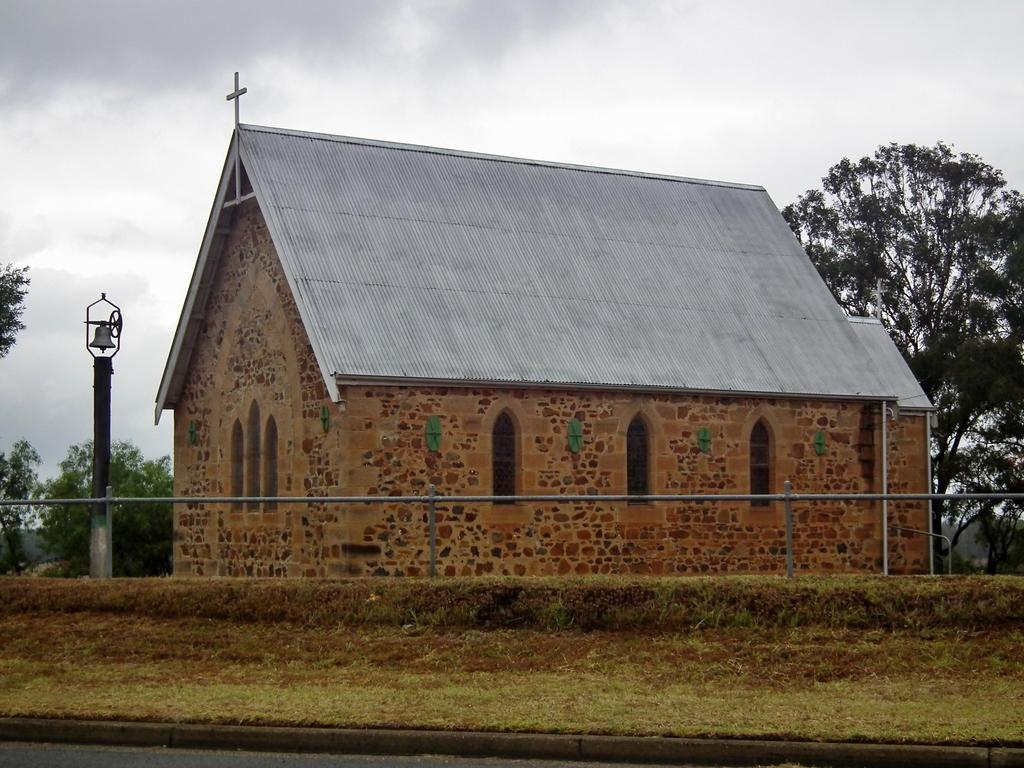What type of building is depicted in the image? There is a house with a cross mark at the top in the image. What is attached to the pole in the image? There is a bell on a pole in the image. What type of barrier can be seen in the image? There is a fence in the image in the image. What type of vegetation is present in the image? There are trees in the image. What can be seen in the sky in the image? There are clouds in the sky in the image. What type of insect is controlling the house in the image? There is no insect present in the image, and no control over the house is depicted. 